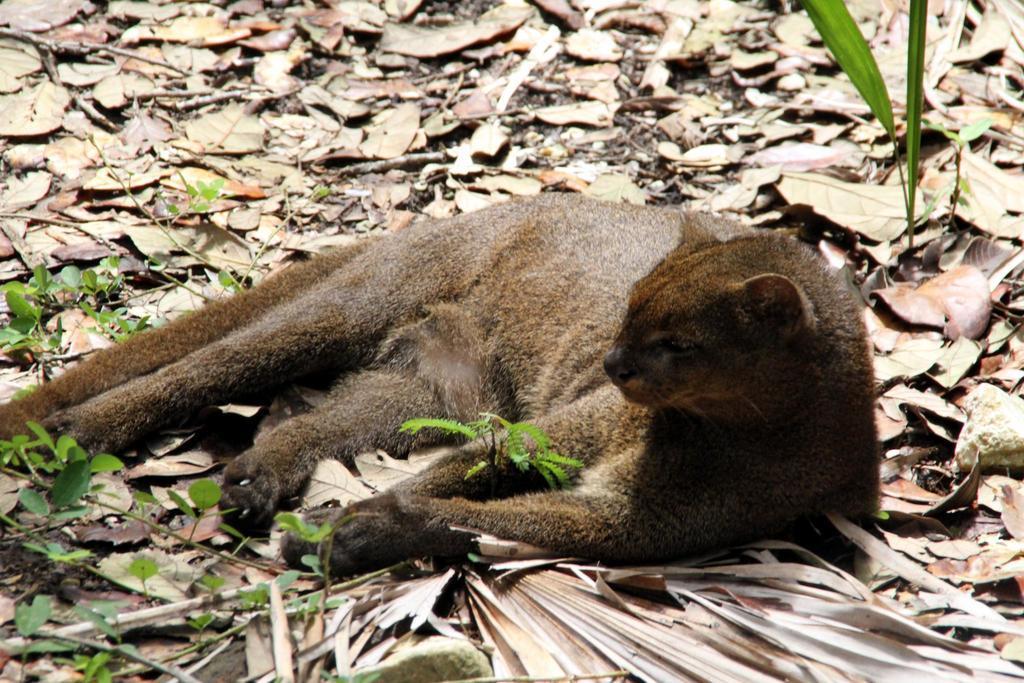Please provide a concise description of this image. In this image we can see an animal lying on the surface. There are few plants in the image. There are many dry leaves on the ground. 